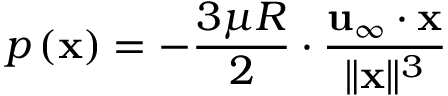<formula> <loc_0><loc_0><loc_500><loc_500>p \left ( x \right ) = - { \frac { 3 \mu R } { 2 } } \cdot { \frac { u _ { \infty } \cdot x } { \| x \| ^ { 3 } } }</formula> 